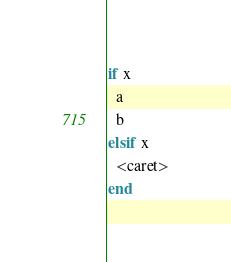Convert code to text. <code><loc_0><loc_0><loc_500><loc_500><_Crystal_>if x
  a
  b
elsif x
  <caret>
end</code> 